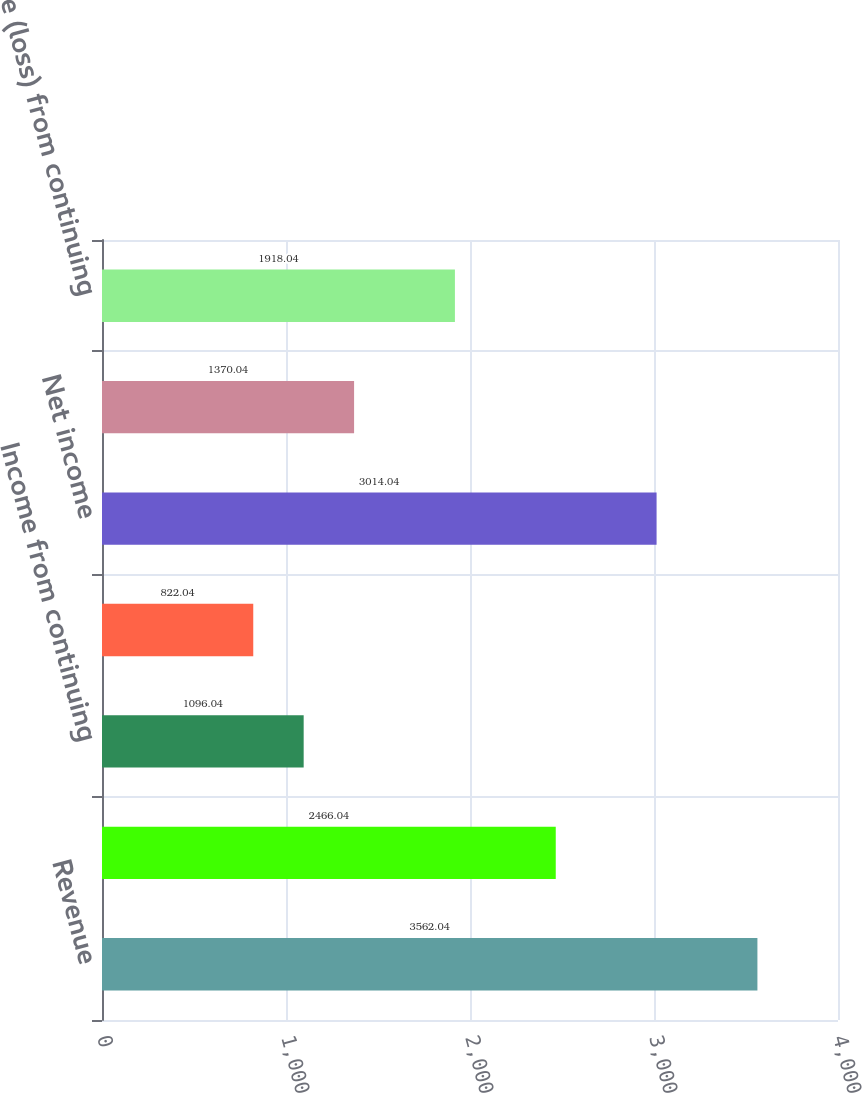Convert chart to OTSL. <chart><loc_0><loc_0><loc_500><loc_500><bar_chart><fcel>Revenue<fcel>Operating margin<fcel>Income from continuing<fcel>Income (loss) from<fcel>Net income<fcel>Net income attributable to The<fcel>Income (loss) from continuing<nl><fcel>3562.04<fcel>2466.04<fcel>1096.04<fcel>822.04<fcel>3014.04<fcel>1370.04<fcel>1918.04<nl></chart> 